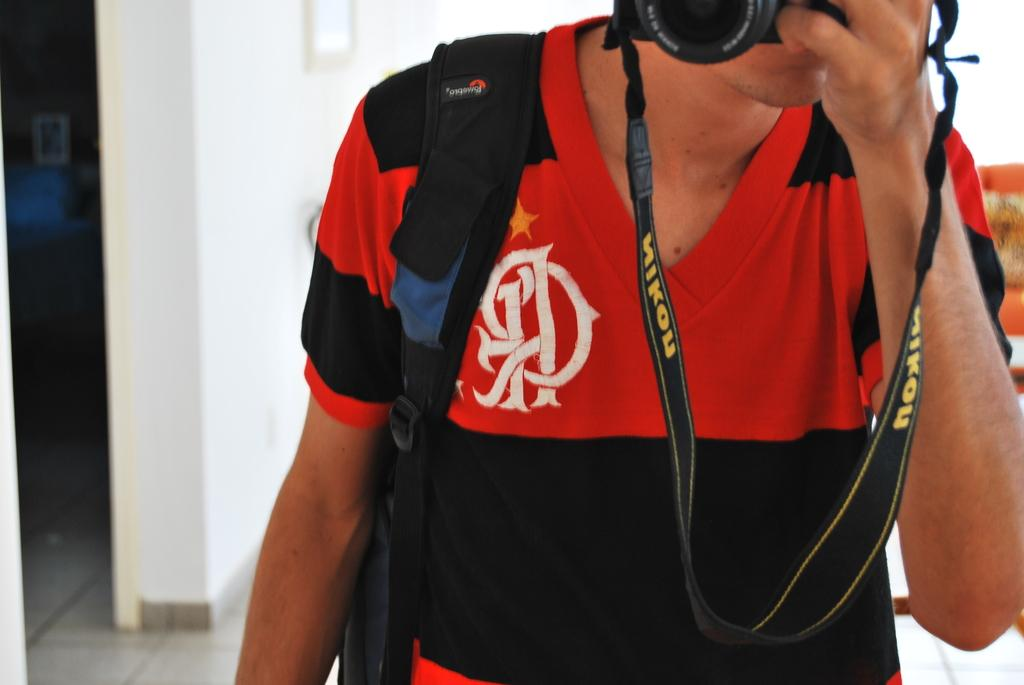<image>
Provide a brief description of the given image. man in black and red shirt holding camera with nikon on strap 